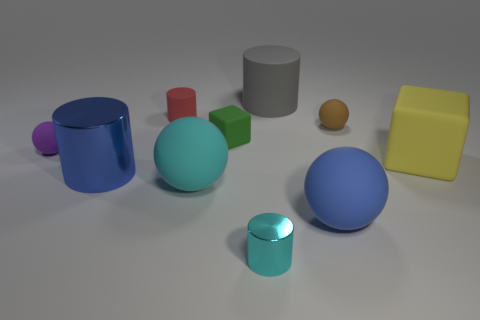Subtract all large rubber cylinders. How many cylinders are left? 3 Subtract all cyan cylinders. How many cylinders are left? 3 Subtract 1 cylinders. How many cylinders are left? 3 Subtract all spheres. How many objects are left? 6 Subtract all green balls. Subtract all purple cylinders. How many balls are left? 4 Subtract all small balls. Subtract all small objects. How many objects are left? 3 Add 2 big blue objects. How many big blue objects are left? 4 Add 9 big cyan balls. How many big cyan balls exist? 10 Subtract 1 yellow cubes. How many objects are left? 9 